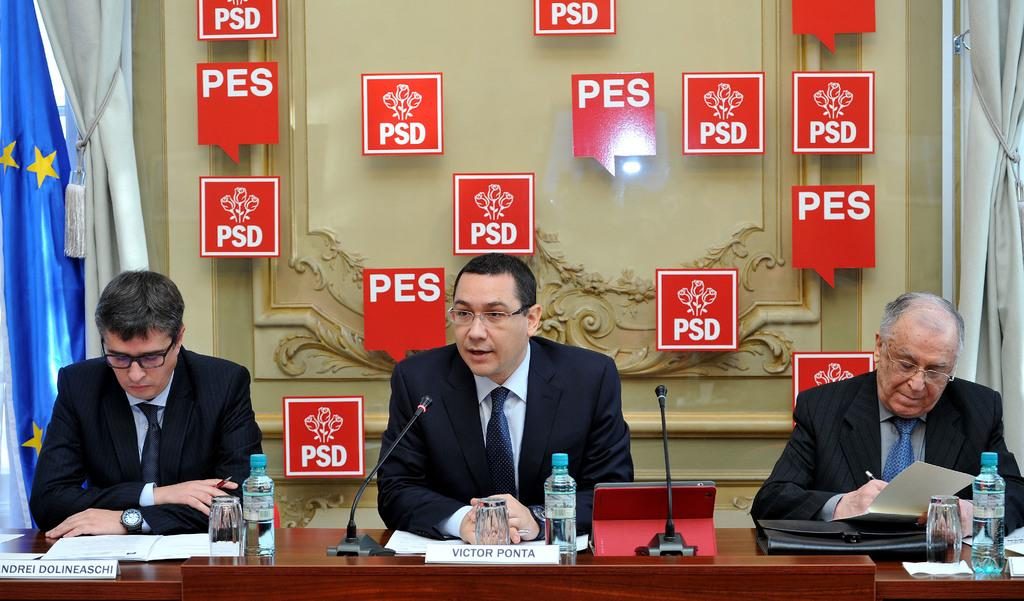<image>
Write a terse but informative summary of the picture. Three men are sitting at a table with red blocks around them saying PSD and PES. 